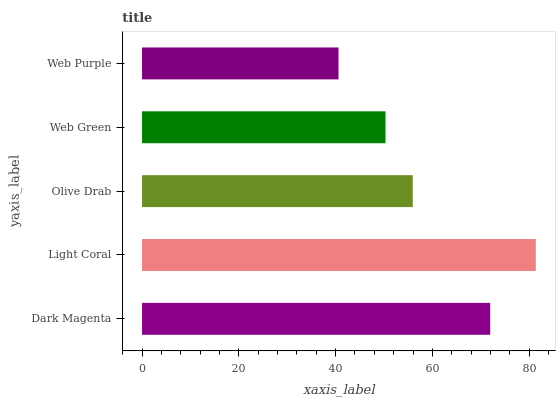Is Web Purple the minimum?
Answer yes or no. Yes. Is Light Coral the maximum?
Answer yes or no. Yes. Is Olive Drab the minimum?
Answer yes or no. No. Is Olive Drab the maximum?
Answer yes or no. No. Is Light Coral greater than Olive Drab?
Answer yes or no. Yes. Is Olive Drab less than Light Coral?
Answer yes or no. Yes. Is Olive Drab greater than Light Coral?
Answer yes or no. No. Is Light Coral less than Olive Drab?
Answer yes or no. No. Is Olive Drab the high median?
Answer yes or no. Yes. Is Olive Drab the low median?
Answer yes or no. Yes. Is Light Coral the high median?
Answer yes or no. No. Is Light Coral the low median?
Answer yes or no. No. 